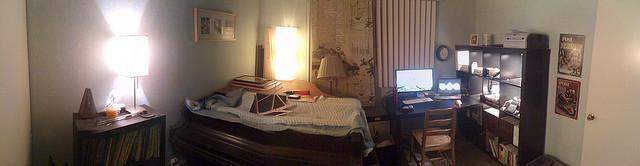How many lights are in the picture?
Give a very brief answer. 2. How many beds are there?
Give a very brief answer. 1. 